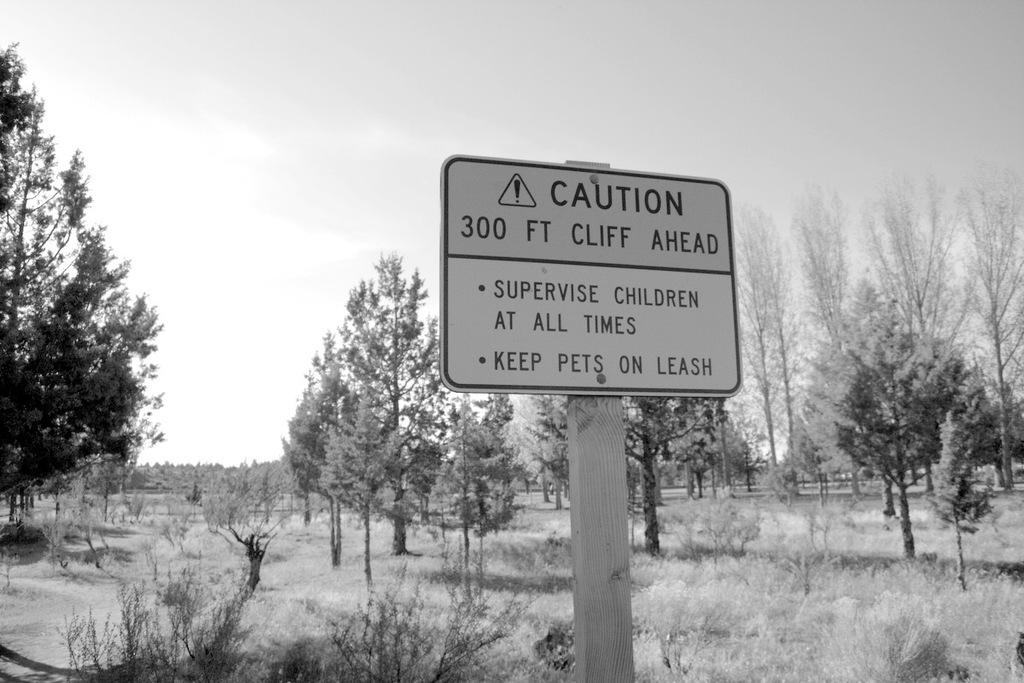What is on the wooden pole in the image? There is a caution board on the wooden pole in the image. What type of vegetation can be seen in the image? Plants and trees are visible in the image. What is the ground covered with in the image? Dried grass is present in the image. What is visible in the background of the image? The sky is visible in the image. What type of pocket can be seen on the caution board in the image? There is no pocket present on the caution board in the image. What kind of calculator is being used by the trees in the image? There are no calculators present in the image, as trees do not use calculators. 